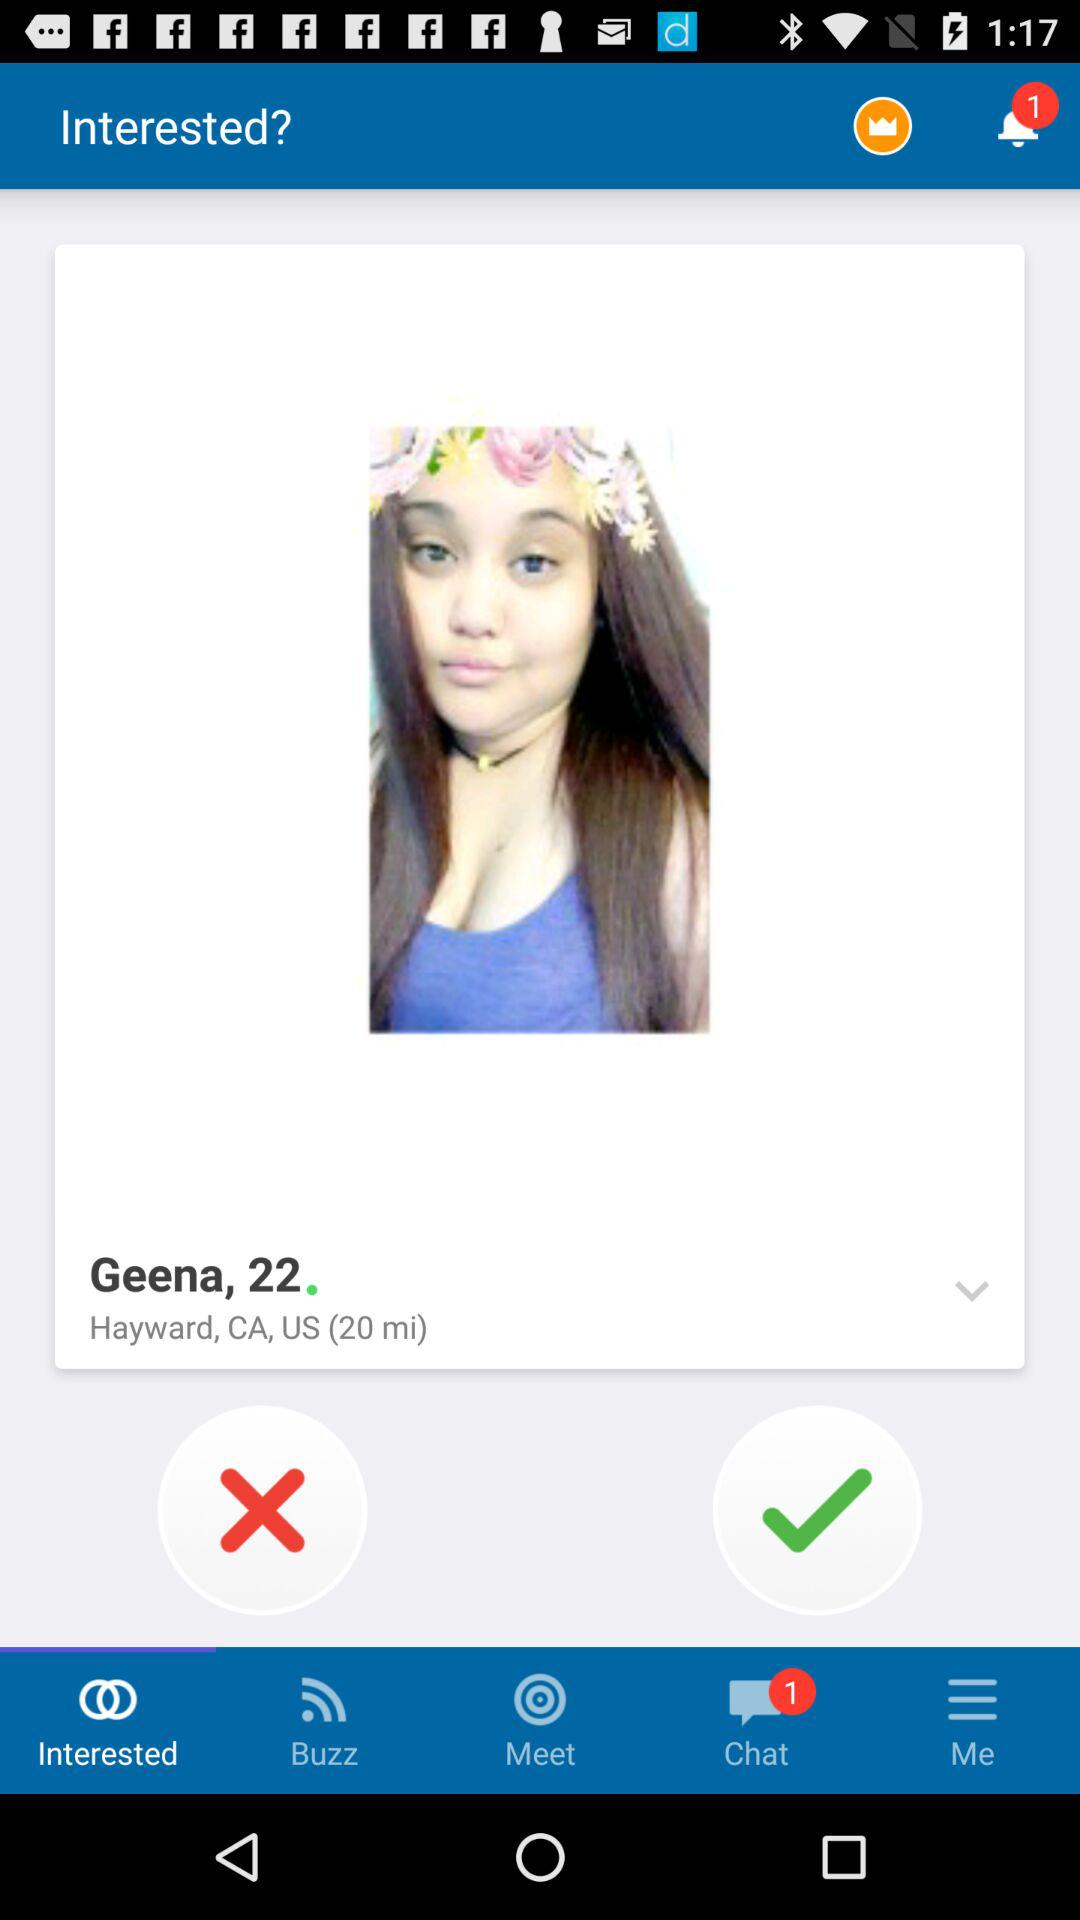What is the girl's age? She is 22 years old. 